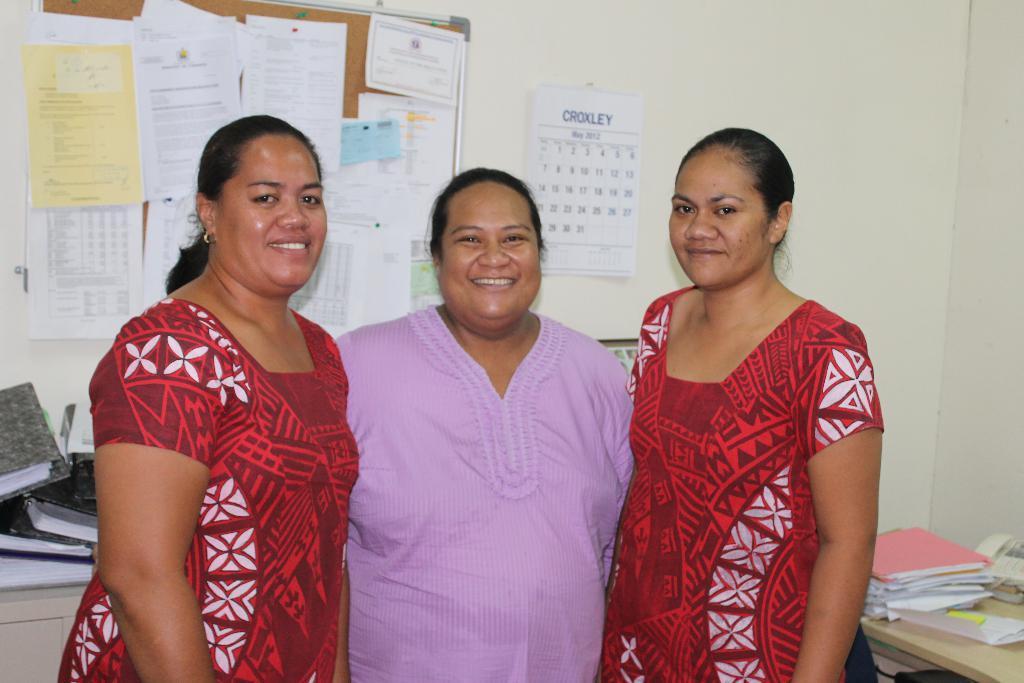Can you describe this image briefly? In this image we can see three women are standing. In the background, we can see papers attached to the notice board and a calendar is attached to the wall. We can see a table, files, a telephone and papers in the right bottom of the image. On the left side of the image, we can see files and a cupboard. 